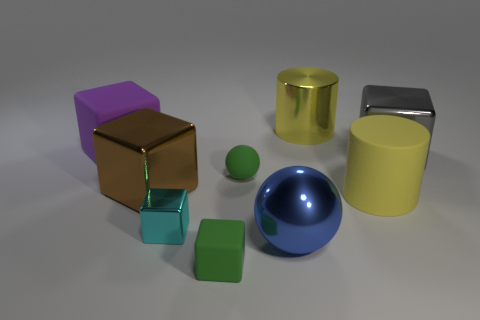The gray thing has what size?
Your response must be concise. Large. There is a brown cube that is the same size as the gray shiny block; what is it made of?
Provide a short and direct response. Metal. There is a cyan object; what number of cyan metal things are on the right side of it?
Provide a succinct answer. 0. Is the small cube that is behind the green rubber block made of the same material as the ball behind the big blue ball?
Give a very brief answer. No. The large thing that is to the left of the big brown object in front of the big thing that is behind the large purple block is what shape?
Your answer should be very brief. Cube. What is the shape of the small cyan thing?
Keep it short and to the point. Cube. There is a purple matte object that is the same size as the blue shiny sphere; what shape is it?
Ensure brevity in your answer.  Cube. How many other objects are the same color as the matte sphere?
Offer a very short reply. 1. There is a large yellow object that is left of the yellow rubber cylinder; is its shape the same as the large yellow object that is in front of the big gray object?
Your answer should be compact. Yes. What number of objects are things to the right of the shiny sphere or big metallic objects in front of the purple object?
Offer a very short reply. 5. 